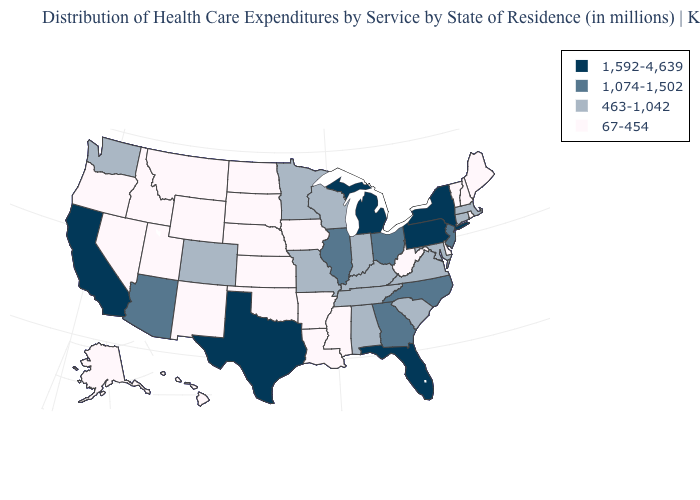What is the value of Vermont?
Concise answer only. 67-454. Does the map have missing data?
Concise answer only. No. Name the states that have a value in the range 67-454?
Write a very short answer. Alaska, Arkansas, Delaware, Hawaii, Idaho, Iowa, Kansas, Louisiana, Maine, Mississippi, Montana, Nebraska, Nevada, New Hampshire, New Mexico, North Dakota, Oklahoma, Oregon, Rhode Island, South Dakota, Utah, Vermont, West Virginia, Wyoming. What is the highest value in the MidWest ?
Answer briefly. 1,592-4,639. Name the states that have a value in the range 67-454?
Write a very short answer. Alaska, Arkansas, Delaware, Hawaii, Idaho, Iowa, Kansas, Louisiana, Maine, Mississippi, Montana, Nebraska, Nevada, New Hampshire, New Mexico, North Dakota, Oklahoma, Oregon, Rhode Island, South Dakota, Utah, Vermont, West Virginia, Wyoming. Which states hav the highest value in the West?
Write a very short answer. California. What is the lowest value in the West?
Write a very short answer. 67-454. Name the states that have a value in the range 67-454?
Keep it brief. Alaska, Arkansas, Delaware, Hawaii, Idaho, Iowa, Kansas, Louisiana, Maine, Mississippi, Montana, Nebraska, Nevada, New Hampshire, New Mexico, North Dakota, Oklahoma, Oregon, Rhode Island, South Dakota, Utah, Vermont, West Virginia, Wyoming. What is the value of Kansas?
Write a very short answer. 67-454. What is the lowest value in the USA?
Answer briefly. 67-454. Does Nebraska have the lowest value in the MidWest?
Quick response, please. Yes. What is the value of Kansas?
Keep it brief. 67-454. Name the states that have a value in the range 463-1,042?
Write a very short answer. Alabama, Colorado, Connecticut, Indiana, Kentucky, Maryland, Massachusetts, Minnesota, Missouri, South Carolina, Tennessee, Virginia, Washington, Wisconsin. Name the states that have a value in the range 67-454?
Short answer required. Alaska, Arkansas, Delaware, Hawaii, Idaho, Iowa, Kansas, Louisiana, Maine, Mississippi, Montana, Nebraska, Nevada, New Hampshire, New Mexico, North Dakota, Oklahoma, Oregon, Rhode Island, South Dakota, Utah, Vermont, West Virginia, Wyoming. What is the value of Virginia?
Concise answer only. 463-1,042. 